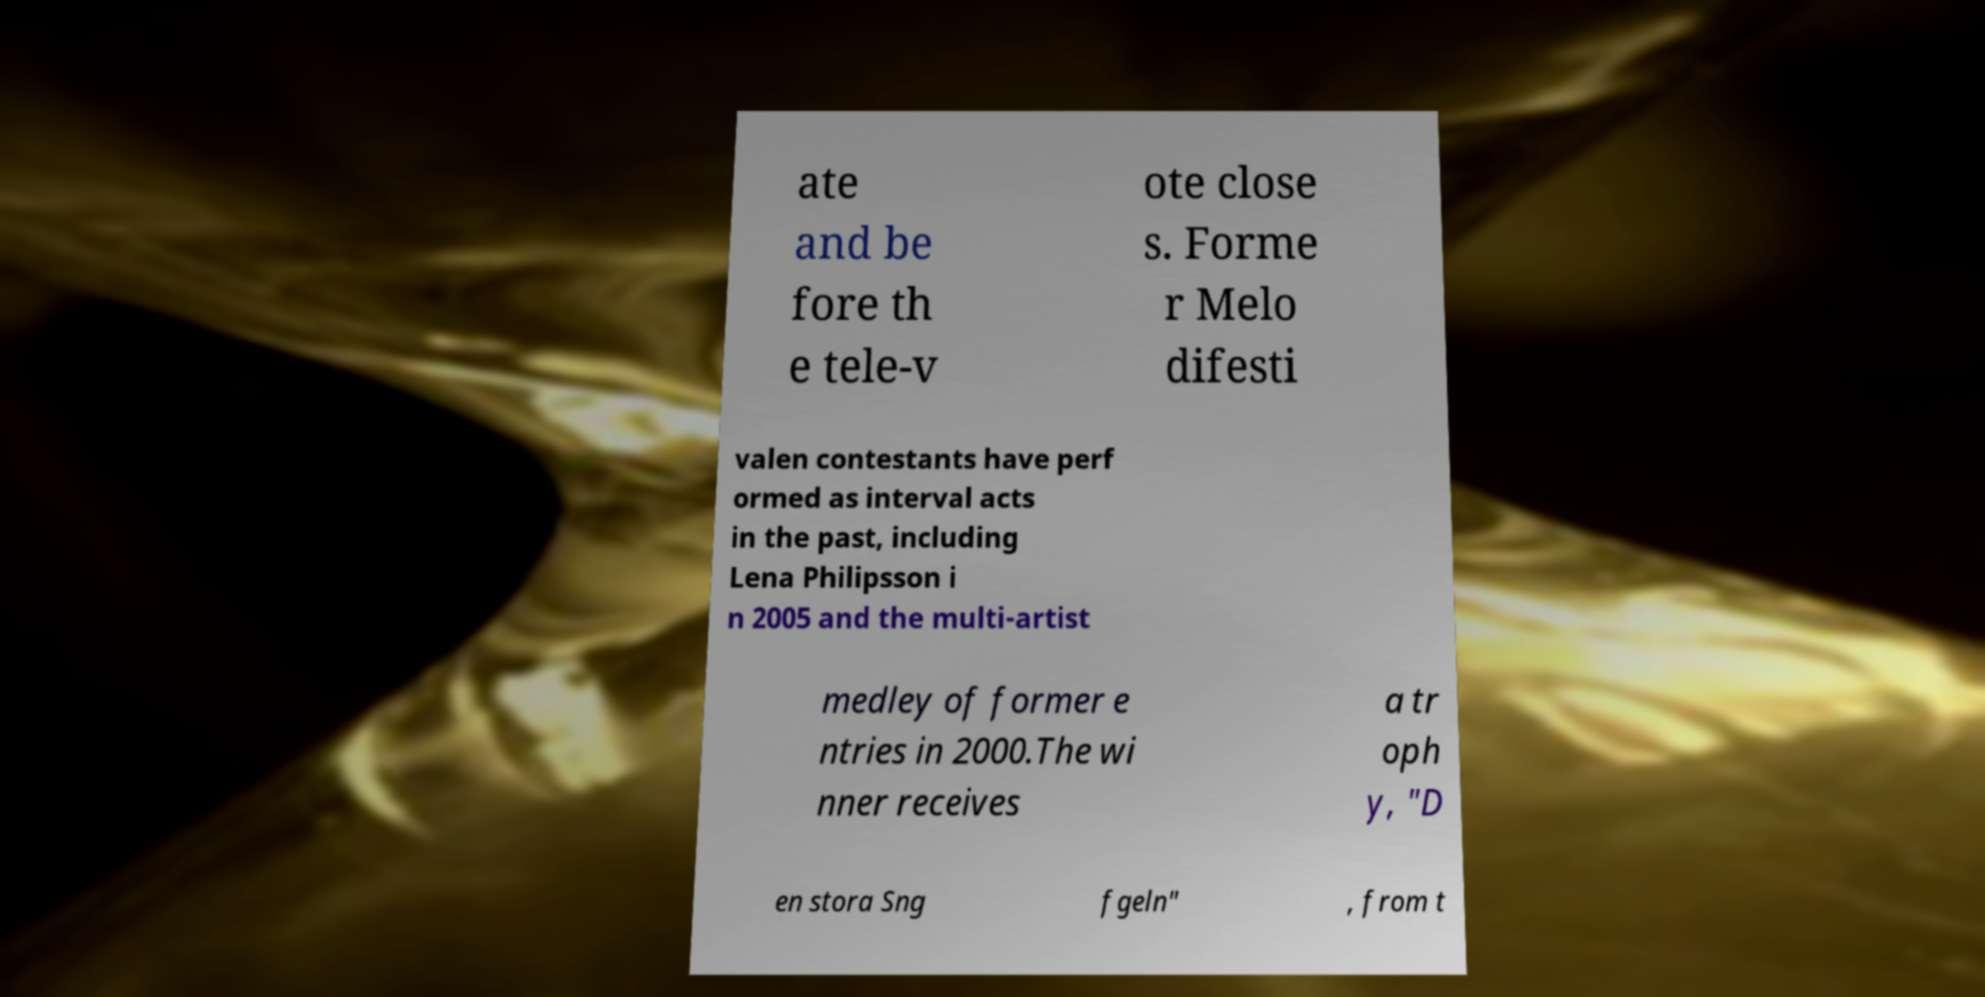For documentation purposes, I need the text within this image transcribed. Could you provide that? ate and be fore th e tele-v ote close s. Forme r Melo difesti valen contestants have perf ormed as interval acts in the past, including Lena Philipsson i n 2005 and the multi-artist medley of former e ntries in 2000.The wi nner receives a tr oph y, "D en stora Sng fgeln" , from t 